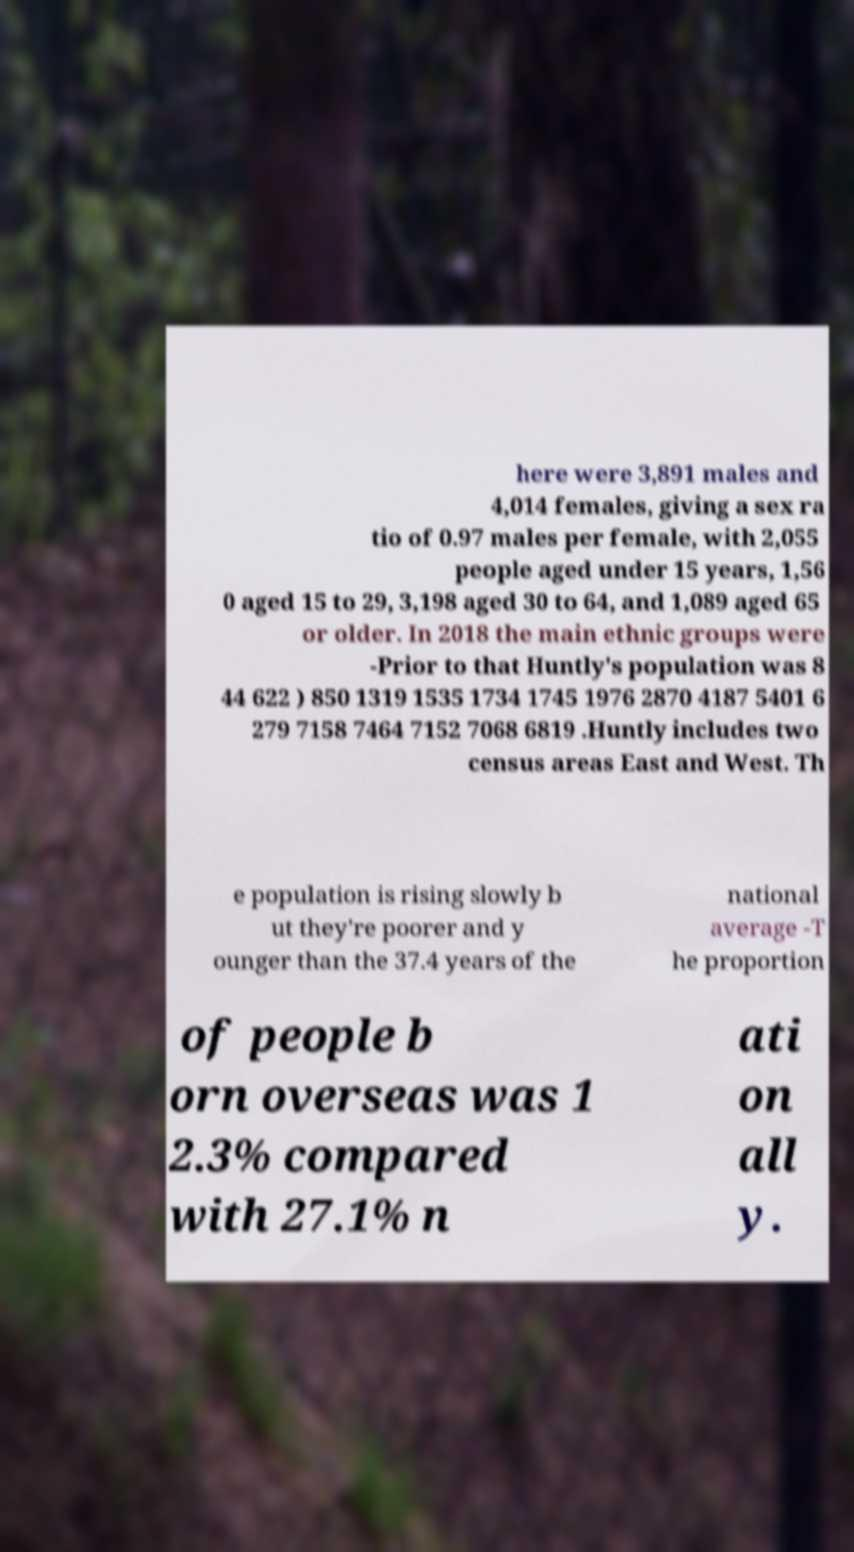For documentation purposes, I need the text within this image transcribed. Could you provide that? here were 3,891 males and 4,014 females, giving a sex ra tio of 0.97 males per female, with 2,055 people aged under 15 years, 1,56 0 aged 15 to 29, 3,198 aged 30 to 64, and 1,089 aged 65 or older. In 2018 the main ethnic groups were -Prior to that Huntly's population was 8 44 622 ) 850 1319 1535 1734 1745 1976 2870 4187 5401 6 279 7158 7464 7152 7068 6819 .Huntly includes two census areas East and West. Th e population is rising slowly b ut they're poorer and y ounger than the 37.4 years of the national average -T he proportion of people b orn overseas was 1 2.3% compared with 27.1% n ati on all y. 